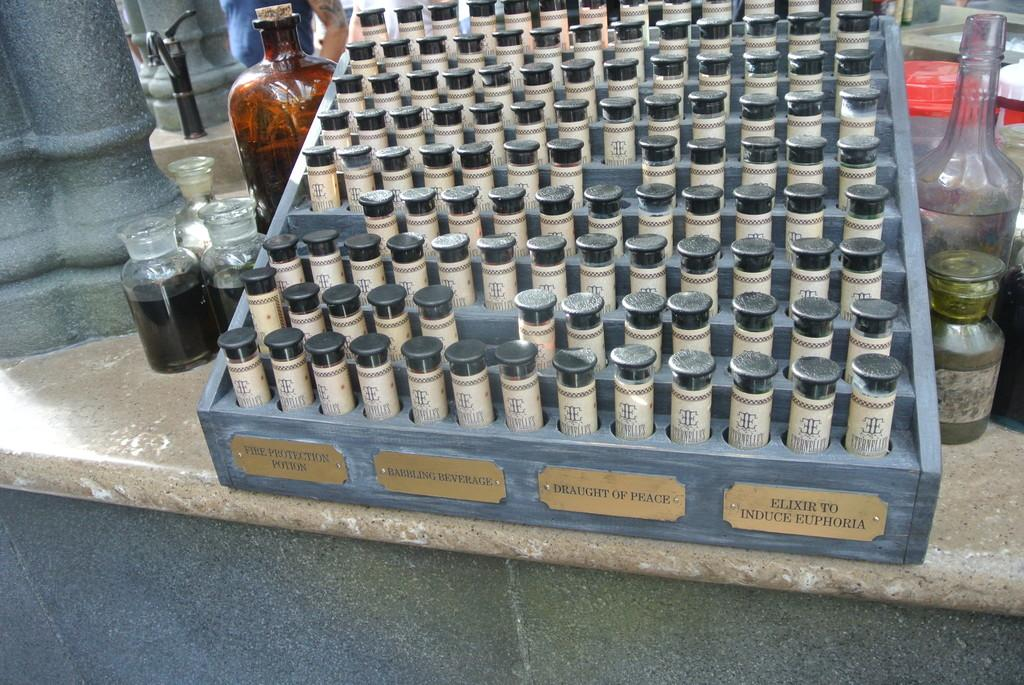<image>
Provide a brief description of the given image. A tray of bottle in a blue case that includes a fire protection potion. 